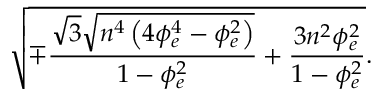<formula> <loc_0><loc_0><loc_500><loc_500>\sqrt { \mp \frac { \sqrt { 3 } \sqrt { n ^ { 4 } \left ( 4 \phi _ { e } ^ { 4 } - \phi _ { e } ^ { 2 } \right ) } } { 1 - \phi _ { e } ^ { 2 } } + \frac { 3 n ^ { 2 } \phi _ { e } ^ { 2 } } { 1 - \phi _ { e } ^ { 2 } } } .</formula> 